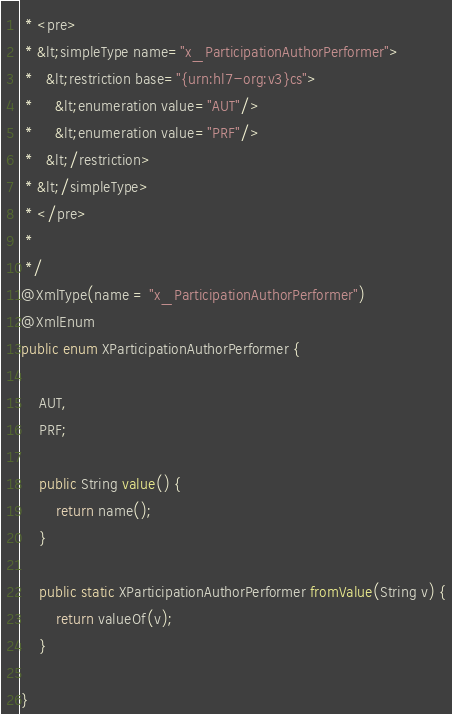<code> <loc_0><loc_0><loc_500><loc_500><_Java_> * <pre>
 * &lt;simpleType name="x_ParticipationAuthorPerformer">
 *   &lt;restriction base="{urn:hl7-org:v3}cs">
 *     &lt;enumeration value="AUT"/>
 *     &lt;enumeration value="PRF"/>
 *   &lt;/restriction>
 * &lt;/simpleType>
 * </pre>
 * 
 */
@XmlType(name = "x_ParticipationAuthorPerformer")
@XmlEnum
public enum XParticipationAuthorPerformer {

    AUT,
    PRF;

    public String value() {
        return name();
    }

    public static XParticipationAuthorPerformer fromValue(String v) {
        return valueOf(v);
    }

}
</code> 